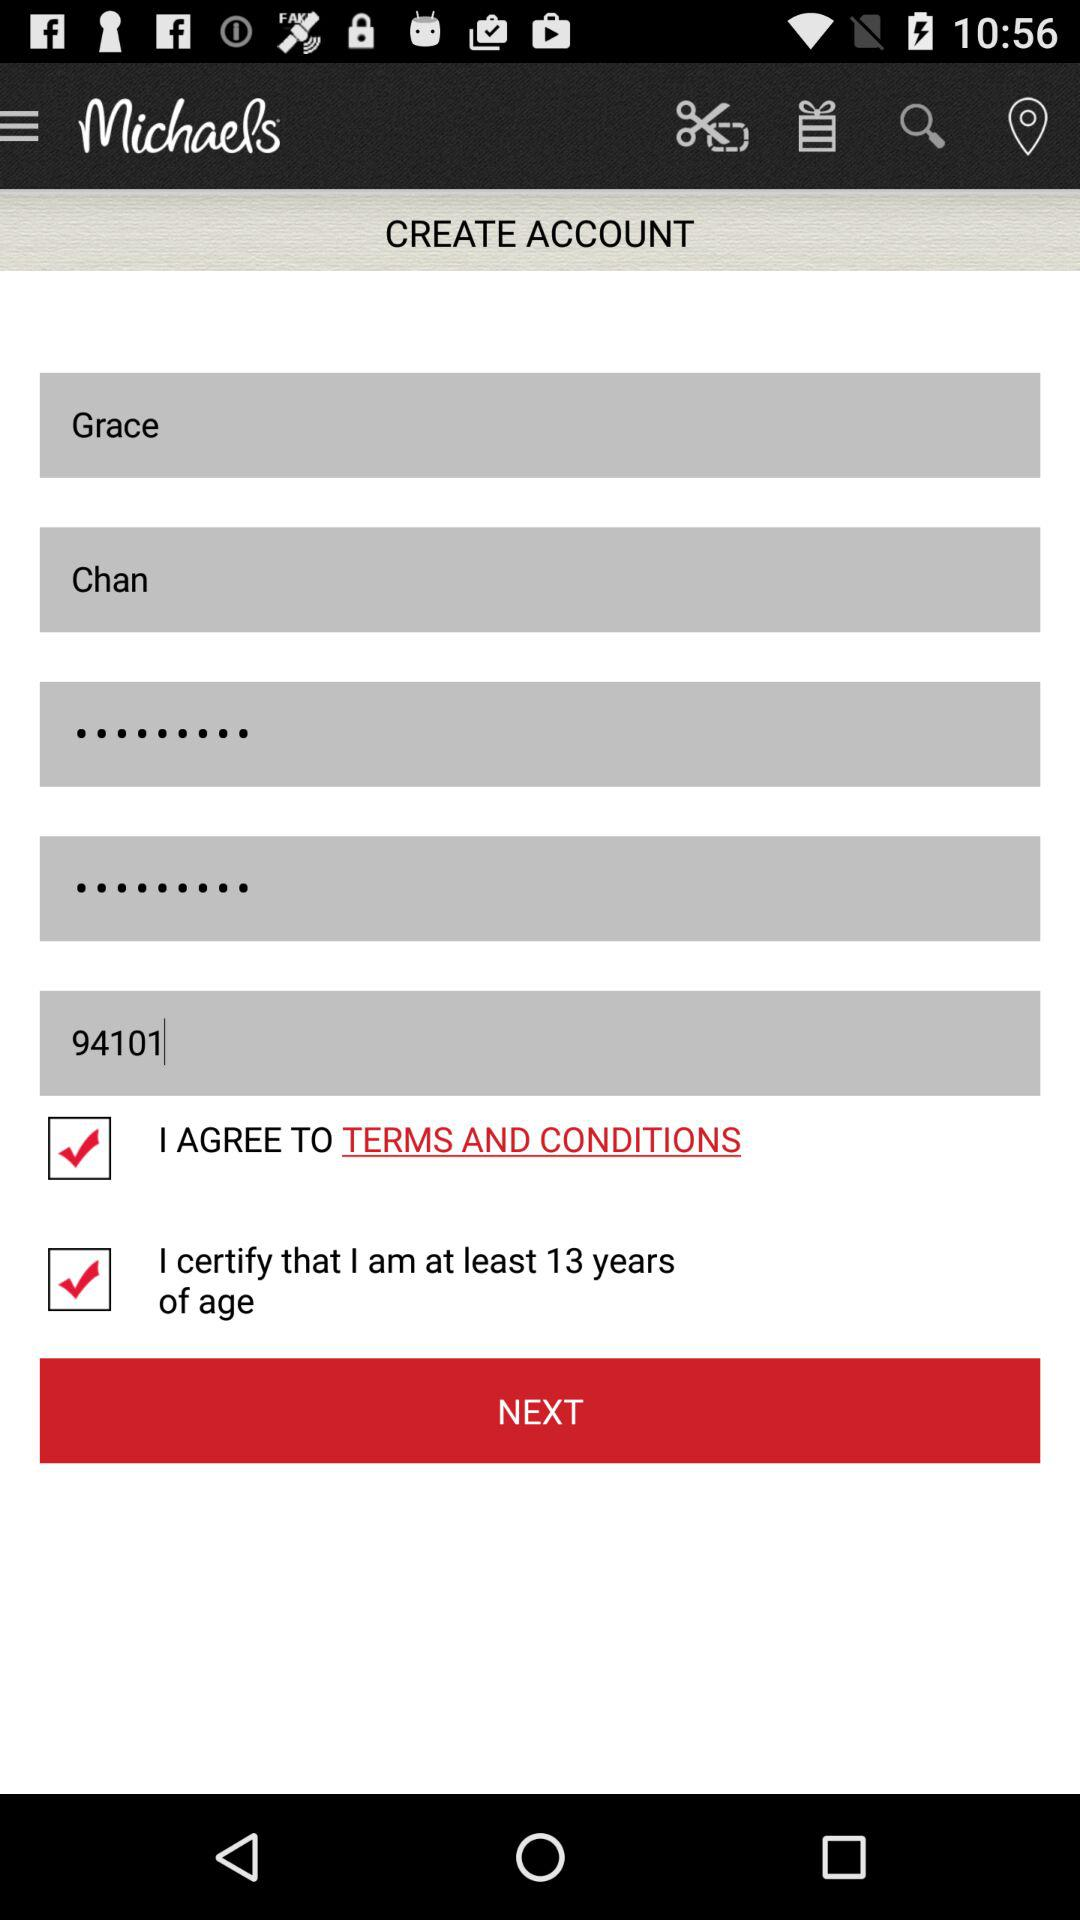What is the first name? The first name is Grace. 